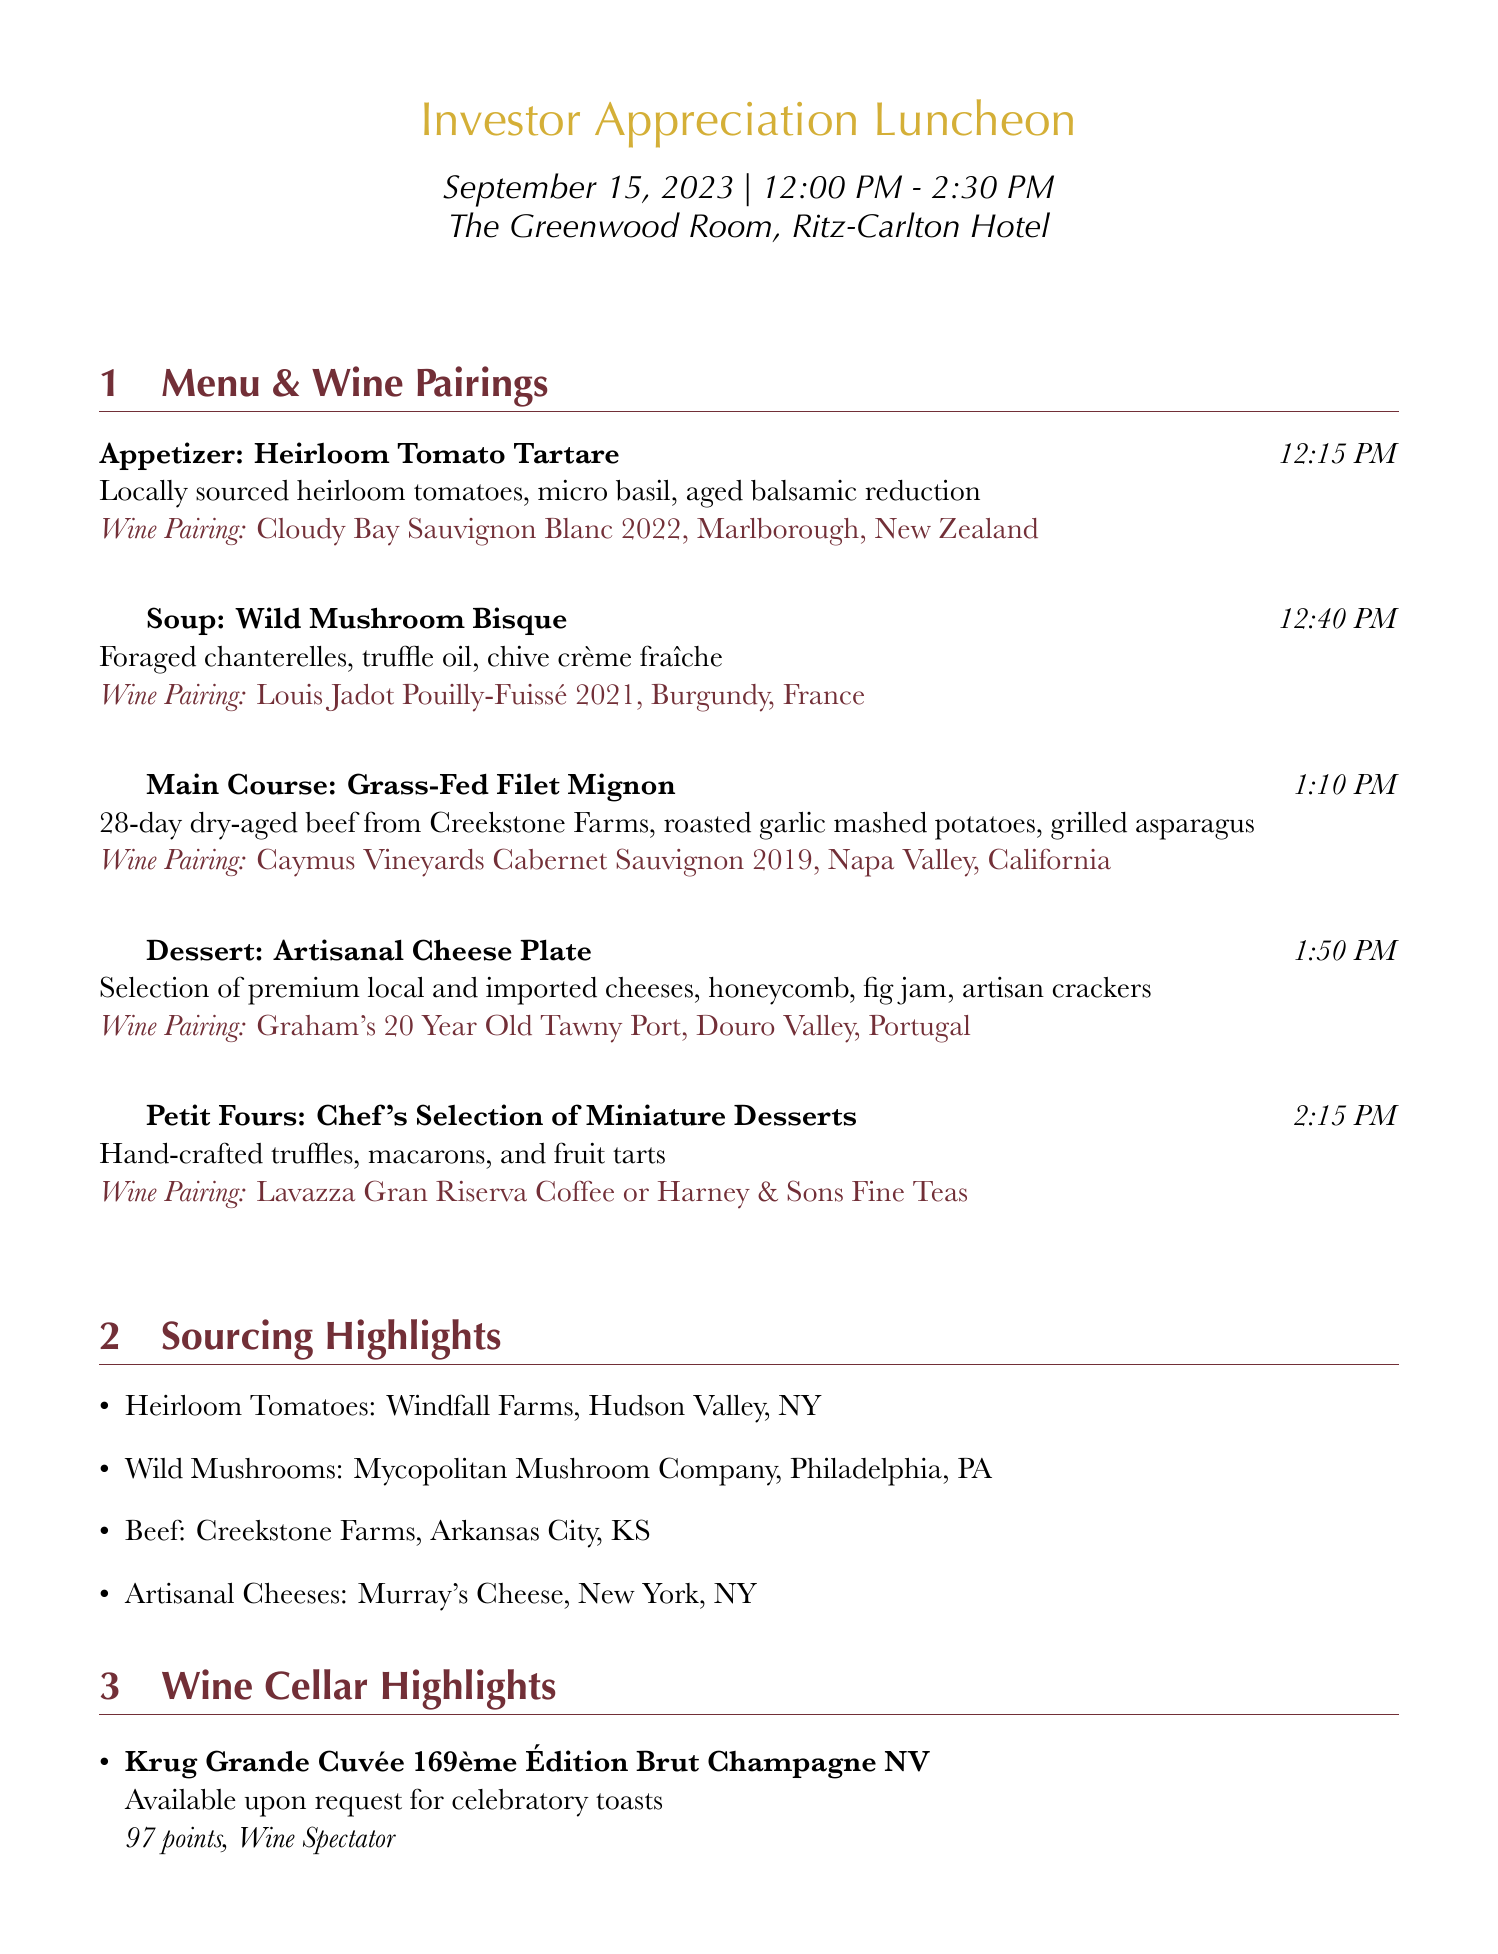What is the event name? The event name is provided at the top of the document under "Investor Appreciation Luncheon."
Answer: Investor Appreciation Luncheon What is the date of the luncheon? The date is explicitly stated in the event details section of the document.
Answer: September 15, 2023 Which dish is paired with the Cloudy Bay Sauvignon Blanc? This pairing is found in the menu section where dishes and their respective wine pairings are listed.
Answer: Heirloom Tomato Tartare What time is the Grass-Fed Filet Mignon served? The serving time is mentioned next to each course within the menu section.
Answer: 1:10 PM Where are the heirloom tomatoes sourced from? The source of the heirloom tomatoes is listed under the sourcing highlights section of the document.
Answer: Windfall Farms, Hudson Valley, NY What dietary options are available? The document outlines dietary restrictions and options available for the luncheon.
Answer: Vegetarian, Vegan, Gluten-Free, Kosher, Halal What accolade does the Château Margaux 2015 receive? This information is specified under the wine cellar highlights section, detailing the accolades of the wines.
Answer: 100 points, Robert Parker's Wine Advocate Which wine is available upon request for celebratory toasts? The document indicates a specific wine available for toasts in the wine cellar highlights section.
Answer: Krug Grande Cuvée 169ème Édition Brut Champagne NV How long before the event do custom menus need to be requested? This detail is included under the special considerations, explaining the timing for requests.
Answer: 48-hour notice 